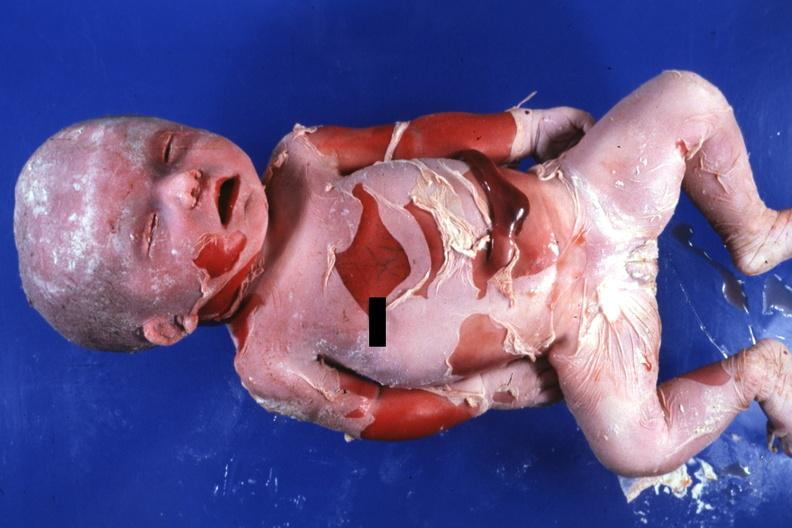s nodular tumor present?
Answer the question using a single word or phrase. No 